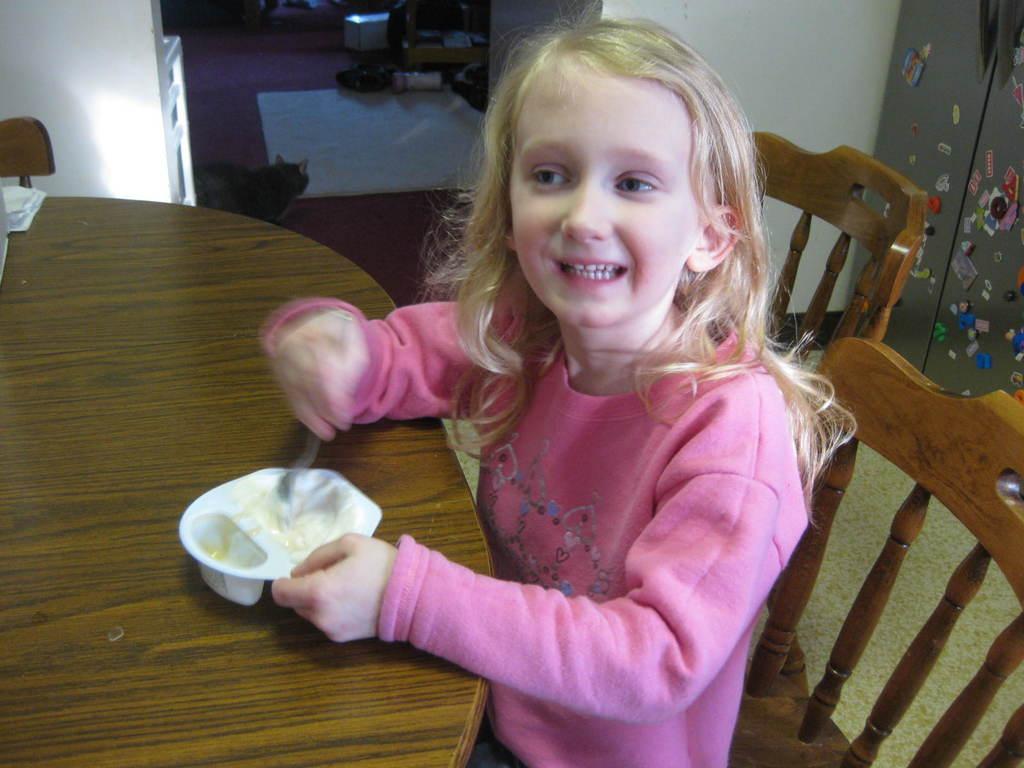Can you describe this image briefly? This is the small girl sitting on the chair and holding a cup and fork. This is a table. I can see a cat. This looks like a floor mat. At background I can see stickers attached to the refrigerator doors. 